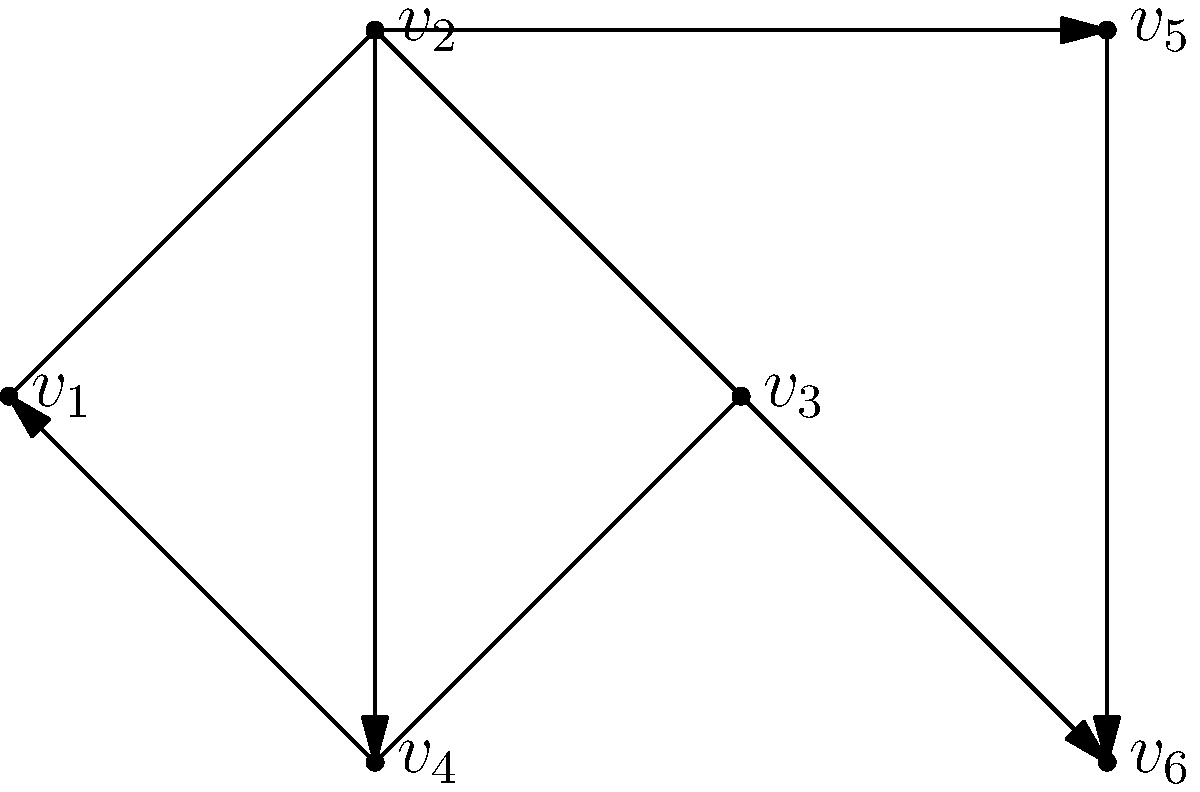In the given directed graph representing a team's communication network, where vertices represent team members and edges represent communication channels, what is the minimum number of edges that need to be added to make the graph strongly connected? To determine the minimum number of edges needed to make the graph strongly connected, we need to follow these steps:

1. Identify the current strongly connected components (SCCs) in the graph.
2. Count the number of SCCs.
3. Calculate the minimum number of edges needed to connect all SCCs.

Step 1: Identify SCCs
- SCC1: $\{v_1, v_2, v_3, v_4\}$
- SCC2: $\{v_5\}$
- SCC3: $\{v_6\}$

Step 2: Count SCCs
There are 3 SCCs in the graph.

Step 3: Calculate minimum edges needed
To make the graph strongly connected, we need to add edges that create a cycle including all SCCs. The minimum number of edges required is equal to the number of SCCs minus 1.

Minimum edges = Number of SCCs - 1
               = 3 - 1
               = 2

Therefore, we need to add 2 edges to make the graph strongly connected. For example, we could add edges from $v_5$ to $v_1$ and from $v_6$ to $v_1$, creating a path from any vertex to any other vertex in the graph.

This solution is particularly relevant for a sports psychology expert, as it demonstrates how to analyze and improve communication networks within a team, ensuring that information can flow effectively between all team members.
Answer: 2 edges 